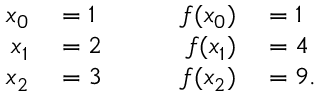<formula> <loc_0><loc_0><loc_500><loc_500>\begin{array} { r l r l r l } { x _ { 0 } } & = 1 } & { f ( x _ { 0 } ) } & = 1 } \\ { x _ { 1 } } & = 2 } & { f ( x _ { 1 } ) } & = 4 } \\ { x _ { 2 } } & = 3 } & { f ( x _ { 2 } ) } & = 9 . } \end{array}</formula> 